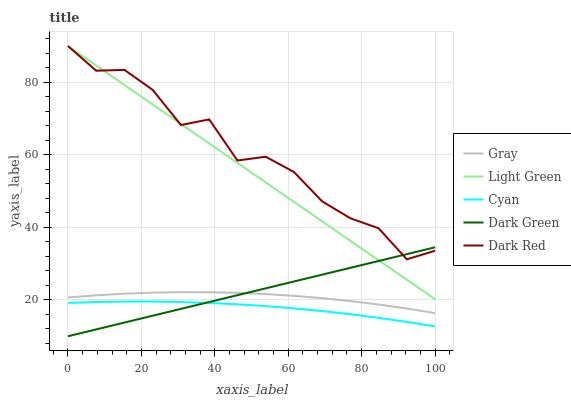Does Cyan have the minimum area under the curve?
Answer yes or no. Yes. Does Dark Red have the maximum area under the curve?
Answer yes or no. Yes. Does Dark Green have the minimum area under the curve?
Answer yes or no. No. Does Dark Green have the maximum area under the curve?
Answer yes or no. No. Is Dark Green the smoothest?
Answer yes or no. Yes. Is Dark Red the roughest?
Answer yes or no. Yes. Is Dark Red the smoothest?
Answer yes or no. No. Is Dark Green the roughest?
Answer yes or no. No. Does Dark Green have the lowest value?
Answer yes or no. Yes. Does Dark Red have the lowest value?
Answer yes or no. No. Does Light Green have the highest value?
Answer yes or no. Yes. Does Dark Green have the highest value?
Answer yes or no. No. Is Gray less than Dark Red?
Answer yes or no. Yes. Is Dark Red greater than Cyan?
Answer yes or no. Yes. Does Dark Green intersect Cyan?
Answer yes or no. Yes. Is Dark Green less than Cyan?
Answer yes or no. No. Is Dark Green greater than Cyan?
Answer yes or no. No. Does Gray intersect Dark Red?
Answer yes or no. No. 